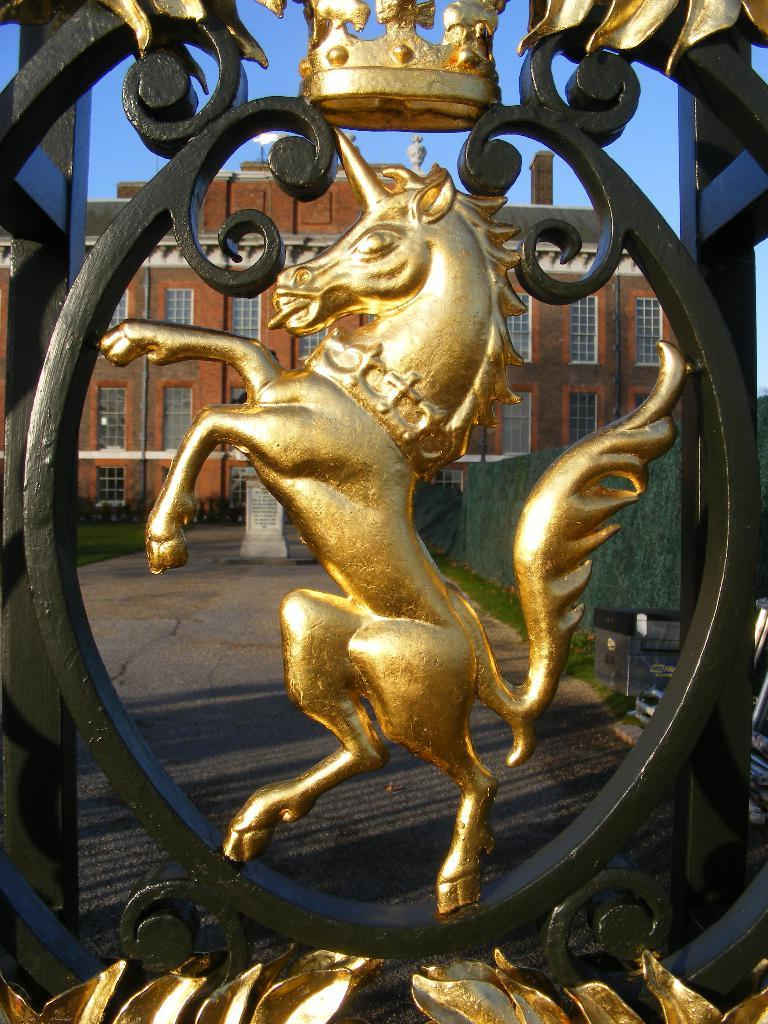What is the main subject of the image? There is a horse sculpture in the image. What is the color of the horse sculpture? The horse sculpture is gold in color. Where is the horse sculpture located in relation to other objects in the image? The horse sculpture is near an iron gate. What can be seen in the background of the image? There is a building and the sky visible in the background of the image. What type of action is the horse sculpture performing in the image? The horse sculpture is a static sculpture and does not perform any actions in the image. 